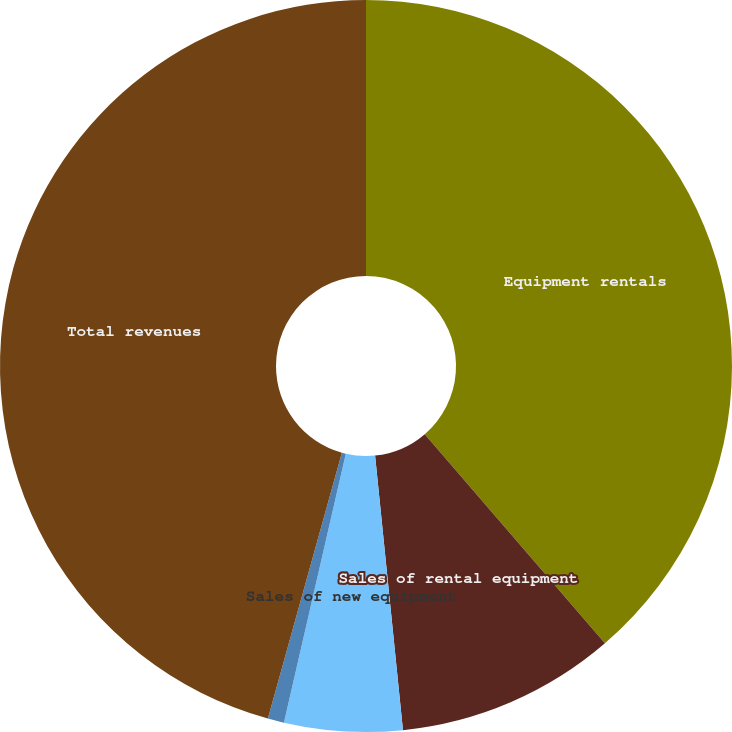Convert chart to OTSL. <chart><loc_0><loc_0><loc_500><loc_500><pie_chart><fcel>Equipment rentals<fcel>Sales of rental equipment<fcel>Sales of new equipment<fcel>Service and other revenues<fcel>Total revenues<nl><fcel>38.68%<fcel>9.71%<fcel>5.21%<fcel>0.72%<fcel>45.68%<nl></chart> 